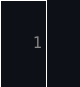<code> <loc_0><loc_0><loc_500><loc_500><_Nim_>





















</code> 